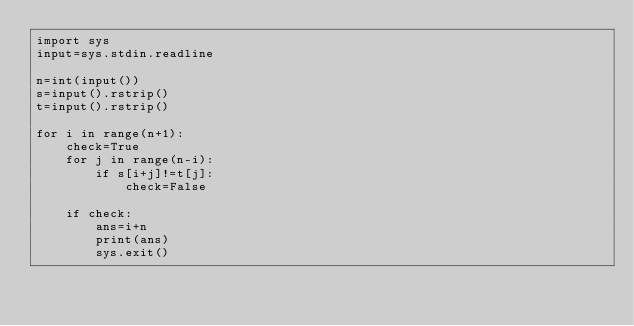<code> <loc_0><loc_0><loc_500><loc_500><_Python_>import sys
input=sys.stdin.readline

n=int(input())
s=input().rstrip()
t=input().rstrip()

for i in range(n+1):
    check=True
    for j in range(n-i):
        if s[i+j]!=t[j]:
            check=False

    if check:
        ans=i+n
        print(ans)
        sys.exit()</code> 